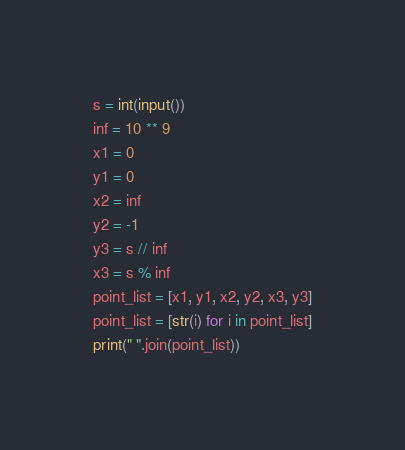Convert code to text. <code><loc_0><loc_0><loc_500><loc_500><_Python_>s = int(input())
inf = 10 ** 9
x1 = 0
y1 = 0
x2 = inf
y2 = -1
y3 = s // inf
x3 = s % inf
point_list = [x1, y1, x2, y2, x3, y3]
point_list = [str(i) for i in point_list]
print(" ".join(point_list))</code> 